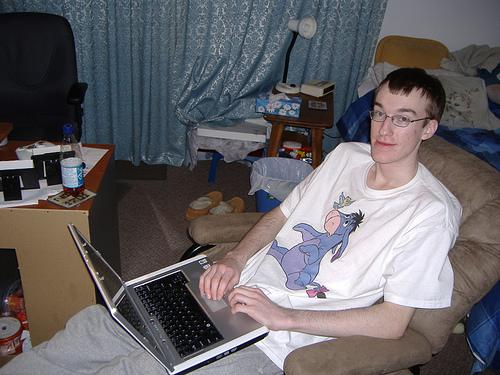What is the can to his side primarily used for?

Choices:
A) soda
B) trash
C) cookies
D) money trash 